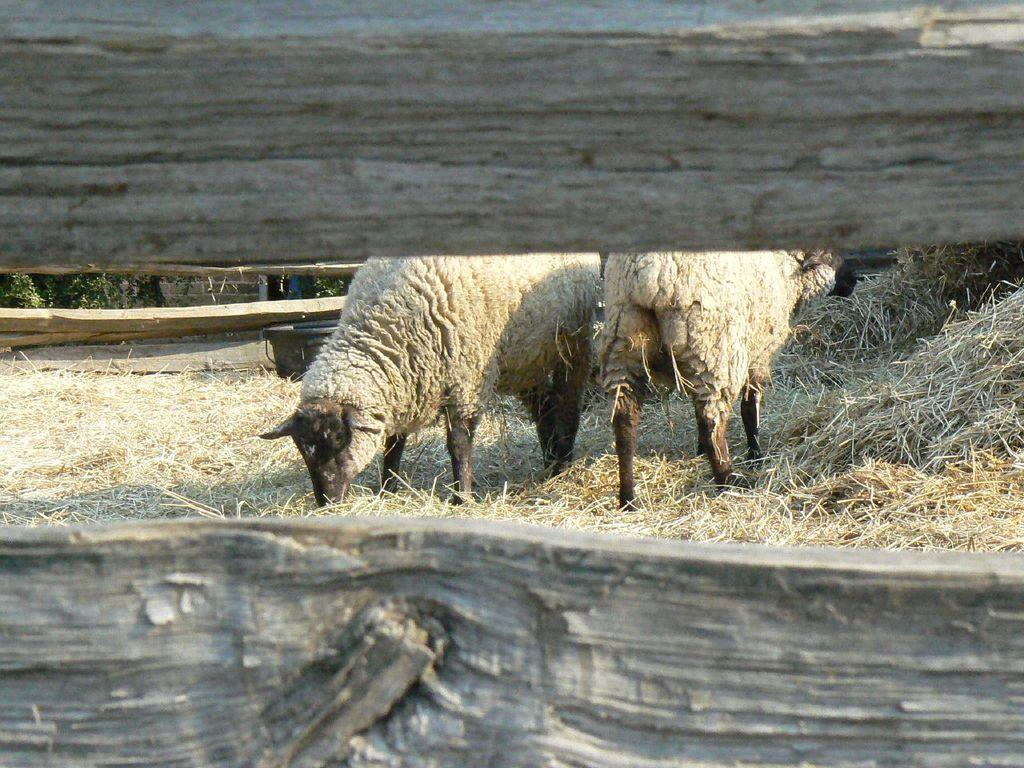How many animals are present in the image? There are two animals in the image. What colors are the animals? The animals are in cream and black color. What type of vegetation can be seen in the image? There is dried grass in the image. What is the purpose of the tub in the image? The purpose of the tub is not specified in the image, but it could be used for holding water or other items. How many trees are visible in the image? There are many trees in the image. What type of fence is present in the image? There is a wooden fence in the image. What type of organization do the animals belong to in the image? There is no indication in the image that the animals belong to any organization. Can you tell me how many times the animals quiver in the image? There is no indication in the image that the animals are quivering, so it cannot be determined. 